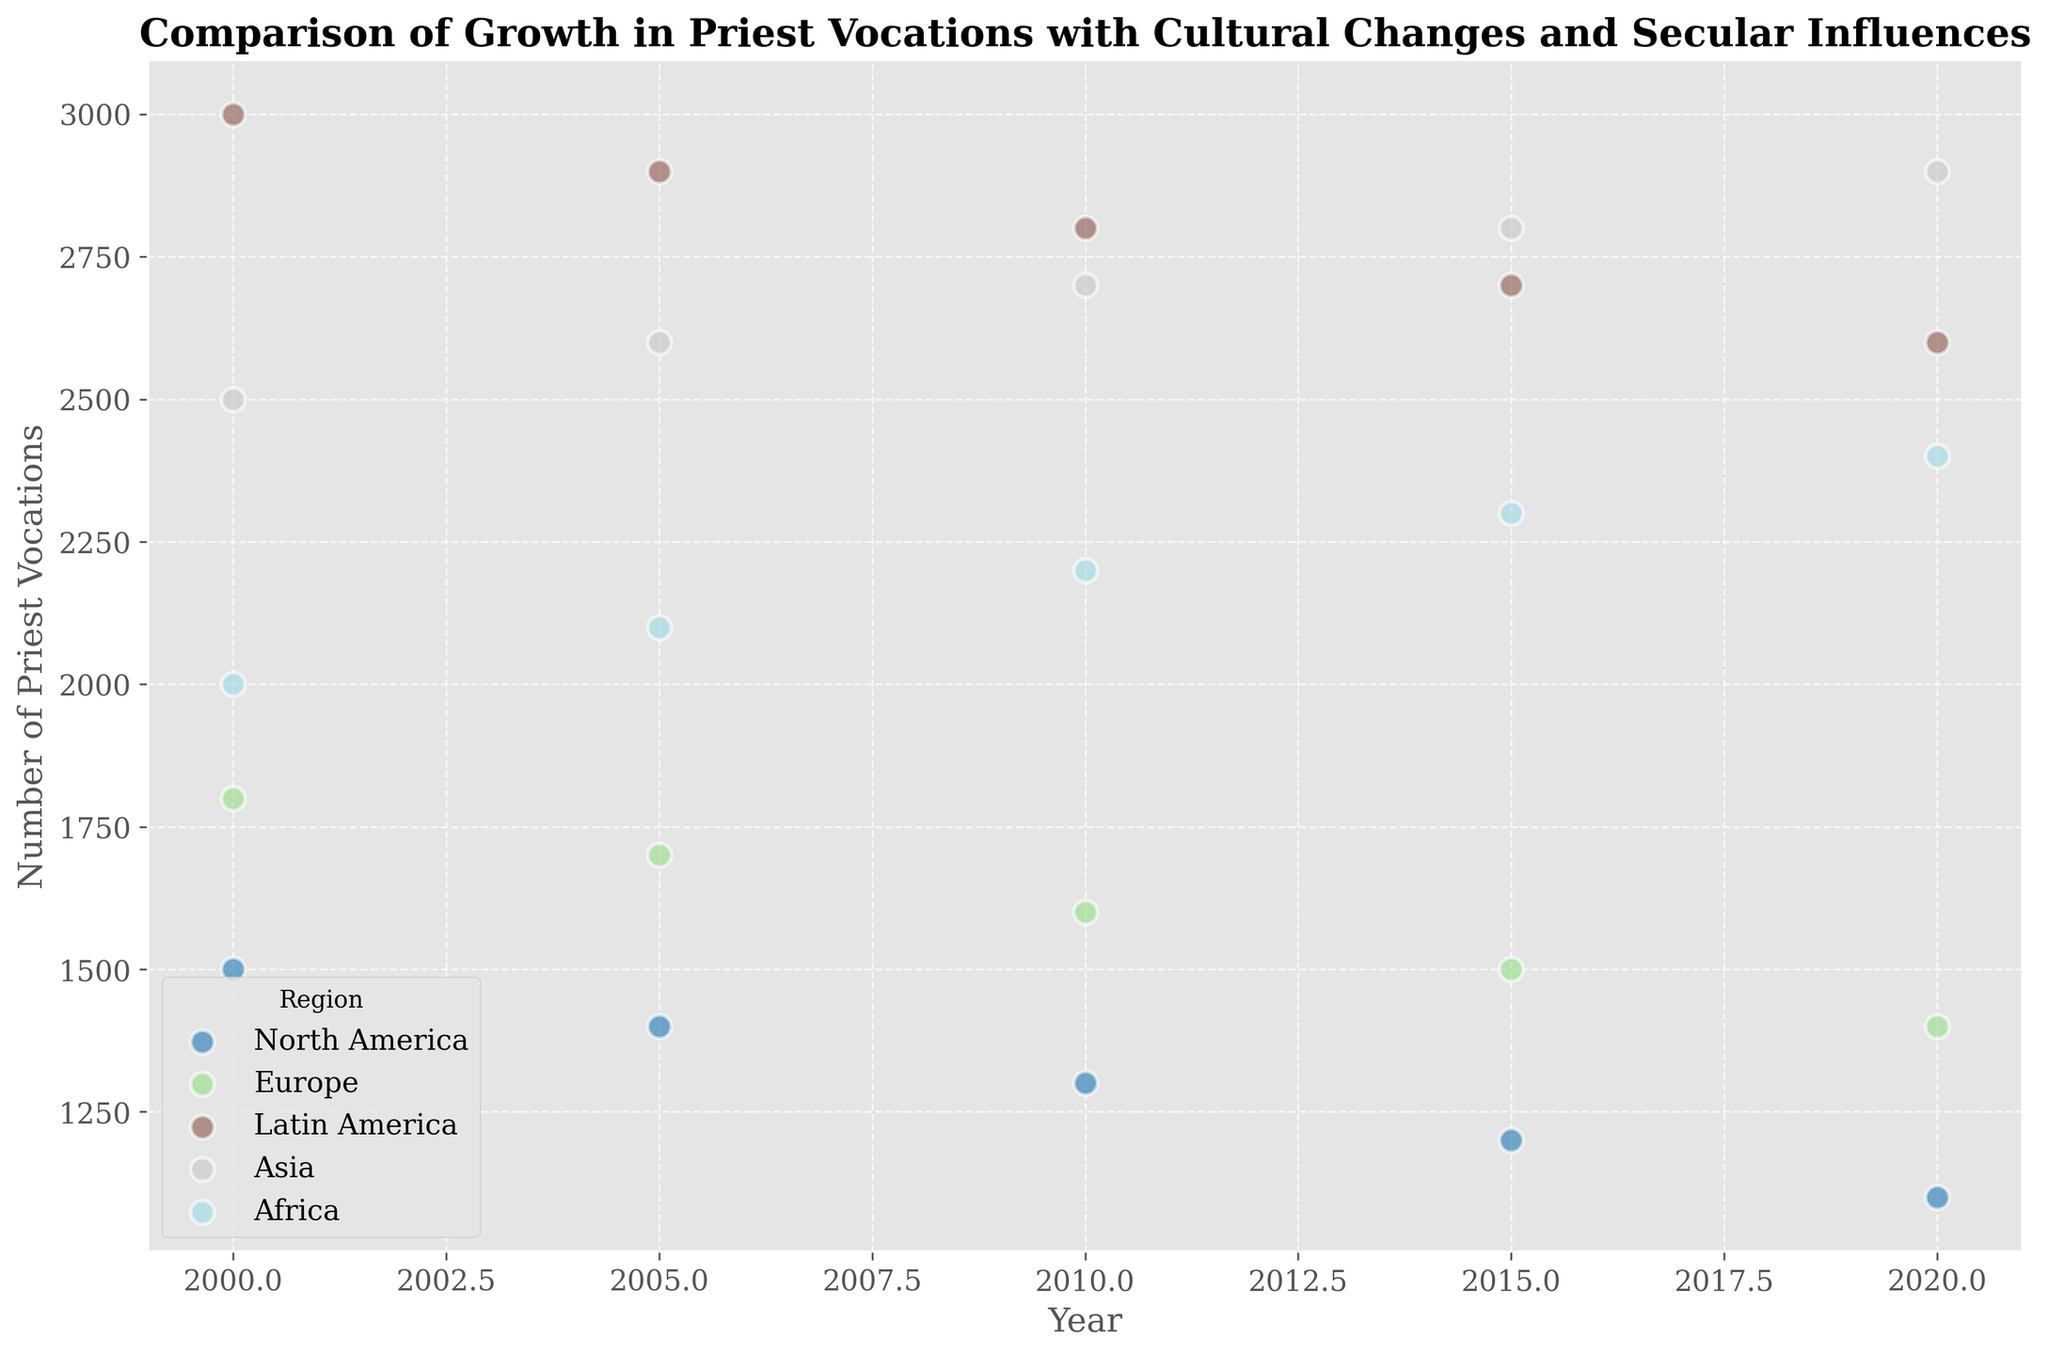What's the trend of priest vocations in North America from 2000 to 2020? The scatter plot shows the number of priest vocations in North America from 2000 to 2020. Observing the slope of the points, the number of priest vocations decreases over time.
Answer: Decreasing Which region shows the highest number of priest vocations in the year 2000? By locating the year 2000 on the x-axis and comparing the heights of the points for each region, Latin America has the highest point among all regions, indicating the highest number of priest vocations.
Answer: Latin America How does the trend in priest vocations in Asia compare to Europe from 2000 to 2020? Analyzing the scatter points from 2000 to 2020 for both Europe and Asia, Asia shows an increasing trend in priest vocations, while Europe shows a decreasing trend.
Answer: Asia increasing, Europe decreasing By 2020, does Latin America or Africa have a higher number of priest vocations? Checking the y-values corresponding to the year 2020 on the x-axis for both Latin America and Africa, Latin America's point is higher than Africa's.
Answer: Latin America What is the percentage decrease in priest vocations in Europe from 2000 to 2020? The number of priest vocations in Europe is 1800 in 2000 and 1400 in 2020. The percentage decrease is calculated as ((1800 - 1400) / 1800) * 100. So, (400 / 1800) * 100 = 22.22%.
Answer: 22.22% Which region shows a consistent increase in priest vocations from 2000 to 2020? Examining the scatter plot for all regions between 2000 and 2020, only Asia consistently shows an upward trend in the number of priest vocations.
Answer: Asia How do the trends in priest vocations compare between North America and Latin America from 2000 to 2020? The scatter points for North America show a consistent decrease in priest vocations, while Latin America shows a gradual decrease, but the decline is less steep compared to North America.
Answer: North America decreasing more steeply, Latin America decreasing less steeply In 2010, which region had the lowest number of priest vocations? Comparing the y-values of the points corresponding to the year 2010 for all regions, North America has the lowest number (1300).
Answer: North America What can be inferred about the Secular Influence Score in relation to the change in priest vocations in North America? From the scatter plot and context provided, as the Secular Influence Score increases in North America from 0.7 to 0.8, the number of priest vocations decreases from 1500 to 1100.
Answer: Increase in Secular Influence, Decrease in vocations What's the average number of priest vocations in Europe over the two decades? Summing the number of priest vocations in Europe for each year (1800 + 1700 + 1600 + 1500 + 1400) and dividing by 5 gives (8000 / 5).
Answer: 1600 